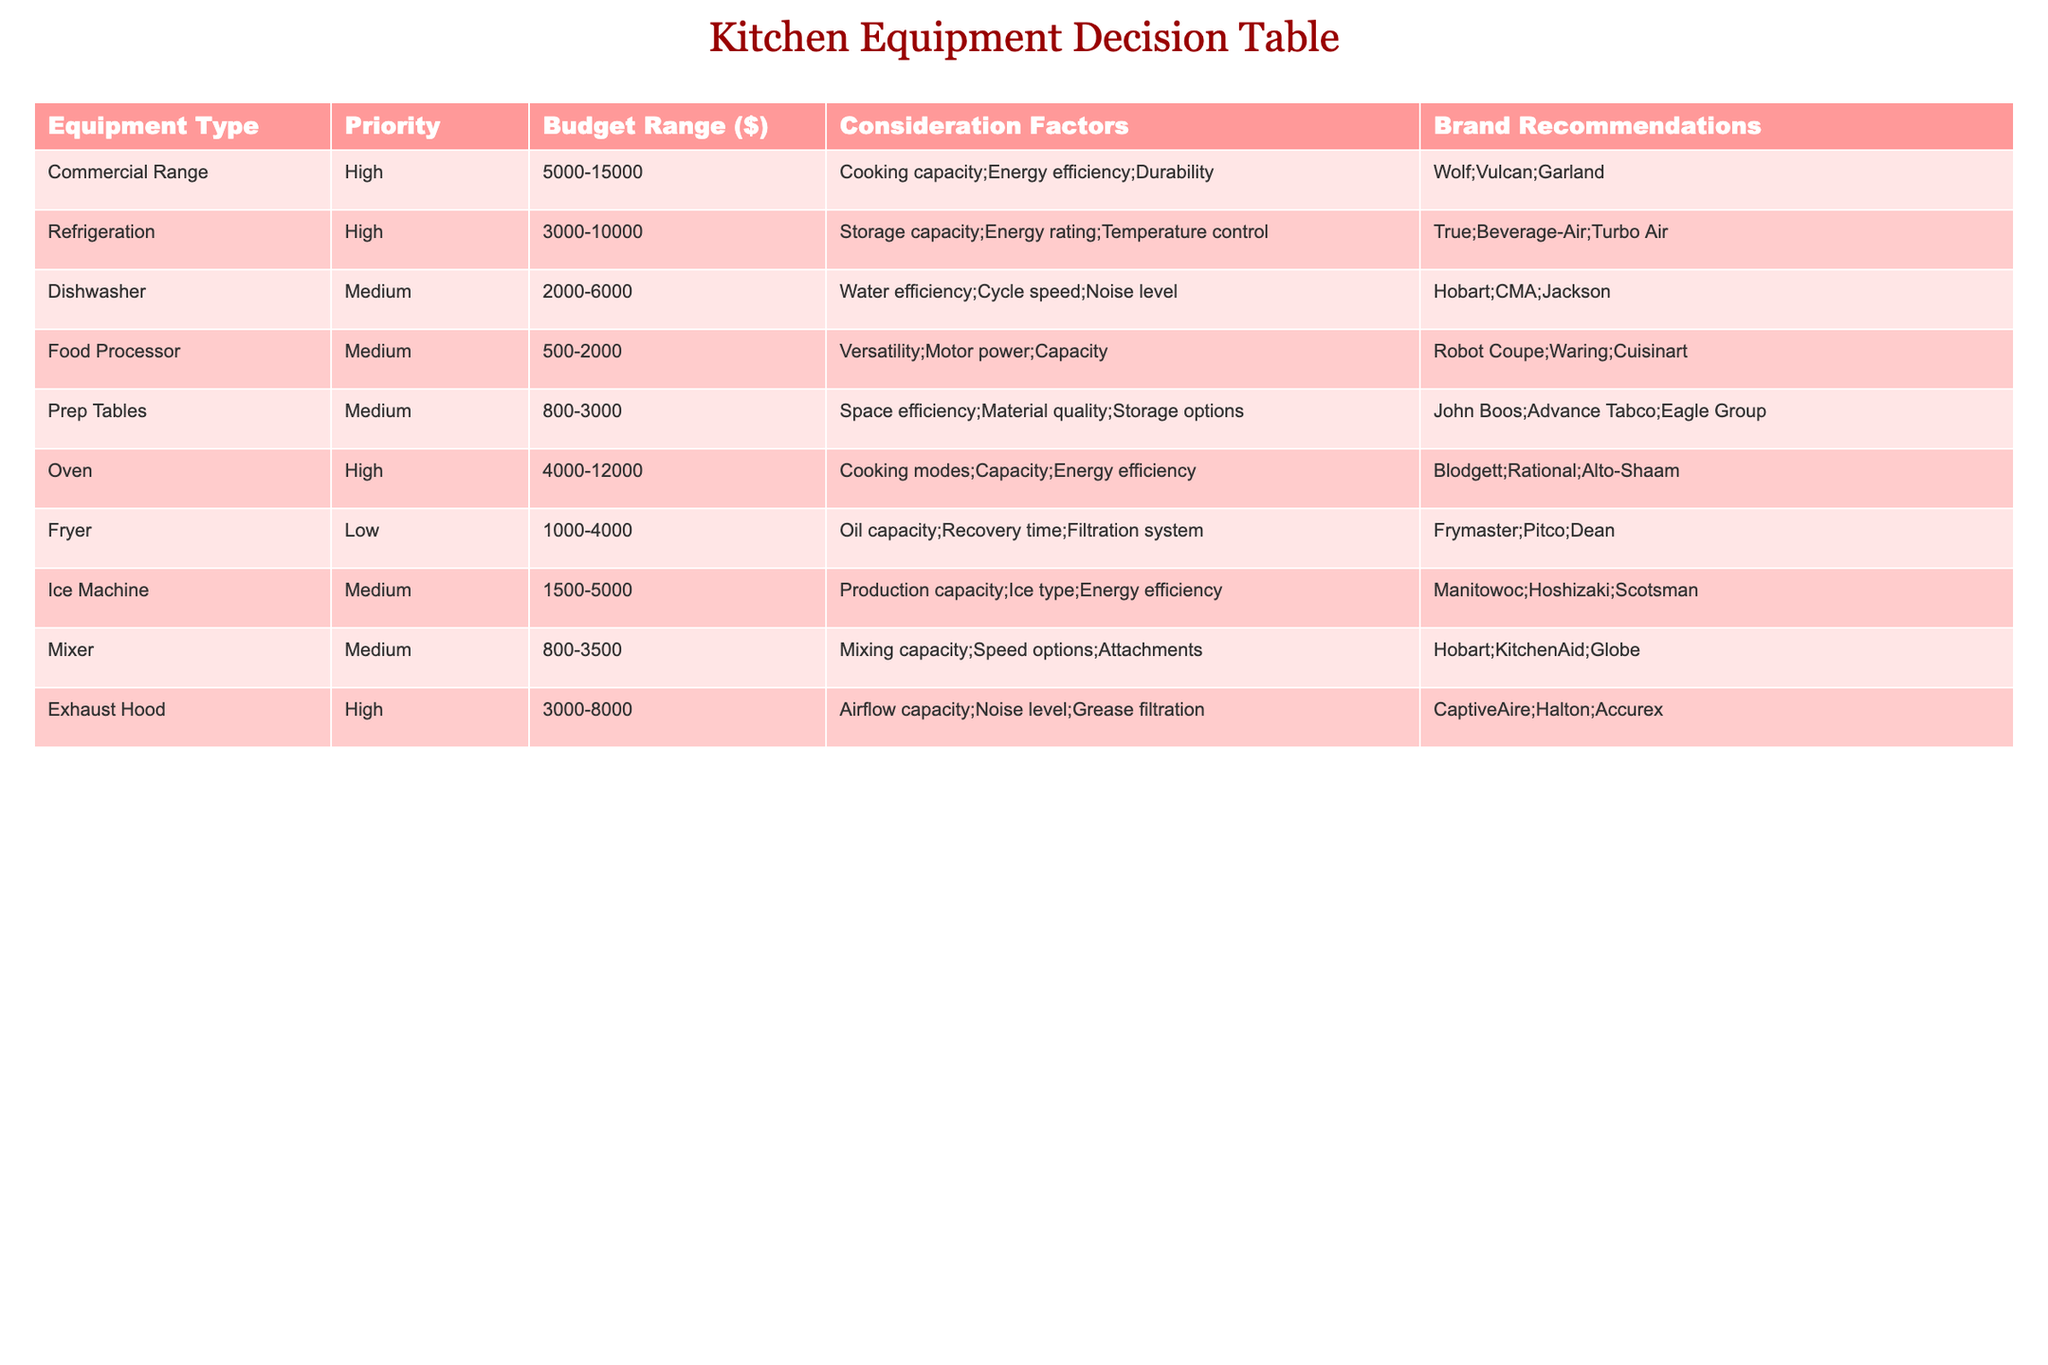What is the highest budget range for refrigeration equipment? The refrigeration equipment row shows the budget range as 3000-10000. This value is the highest mentioned for refrigeration equipment in the table.
Answer: 3000-10000 Which equipment type has the lowest priority? In the table, the fryer is indicated as having a low priority, making it the equipment type with the lowest priority.
Answer: Fryer What is the average budget range for medium priority equipment? The medium priority equipment includes the dishwasher (2000-6000), food processor (500-2000), prep tables (800-3000), ice machine (1500-5000), and mixer (800-3500). The average is calculated as follows: (2000+6000+500+2000+1500+5000+800+3500)/6. This totals to 20700, then dividing by 6 gives approximately 3450.
Answer: 3450 Does the oven equipment have a consideration factor for energy efficiency? Looking at the oven's entry in the table, energy efficiency is listed as one of its consideration factors. Therefore, it does indeed include this aspect.
Answer: Yes What are the brand recommendations for high-priority equipment? The high-priority equipment types include the commercial range, refrigeration, oven, and exhaust hood. Their respective brand recommendations are: Wolf, Vulcan, Garland for commercial range; True, Beverage-Air, Turbo Air for refrigeration; Blodgett, Rational, Alto-Shaam for oven; CaptiveAire, Halton, Accurex for exhaust hood.
Answer: Wolf, Vulcan, Garland; True, Beverage-Air, Turbo Air; Blodgett, Rational, Alto-Shaam; CaptiveAire, Halton, Accurex How many equipment types listed have a priority of medium? The table lists five equipment types with medium priority: dishwasher, food processor, prep tables, ice machine, and mixer. Thus, the count of medium priority equipment is five.
Answer: 5 Is the recommended brand for the food processor the same as that for the mixer? The food processor has brand recommendations of Robot Coupe, Waring, and Cuisinart, while the mixer has Hobart, KitchenAid, and Globe. Since these brands differ, the answer is no.
Answer: No What is the total budget range for the high-priority equipment? The high-priority equipment includes commercial range (5000-15000), refrigeration (3000-10000), oven (4000-12000), and exhaust hood (3000-8000). To find the total, we consider the lower bounds (5000 + 3000 + 4000 + 3000) = 15000 and the upper bounds (15000 + 10000 + 12000 + 8000) = 45000. Thus, the total budget range is 15000-45000.
Answer: 15000-45000 Which equipment has a higher budget range: fryer or mixer? According to the table, the fryer has a budget range of 1000-4000, while the mixer has a budget range of 800-3500. Comparing these ranges, the fryer has a higher upper limit of 4000 versus 3500 for the mixer.
Answer: Fryer 